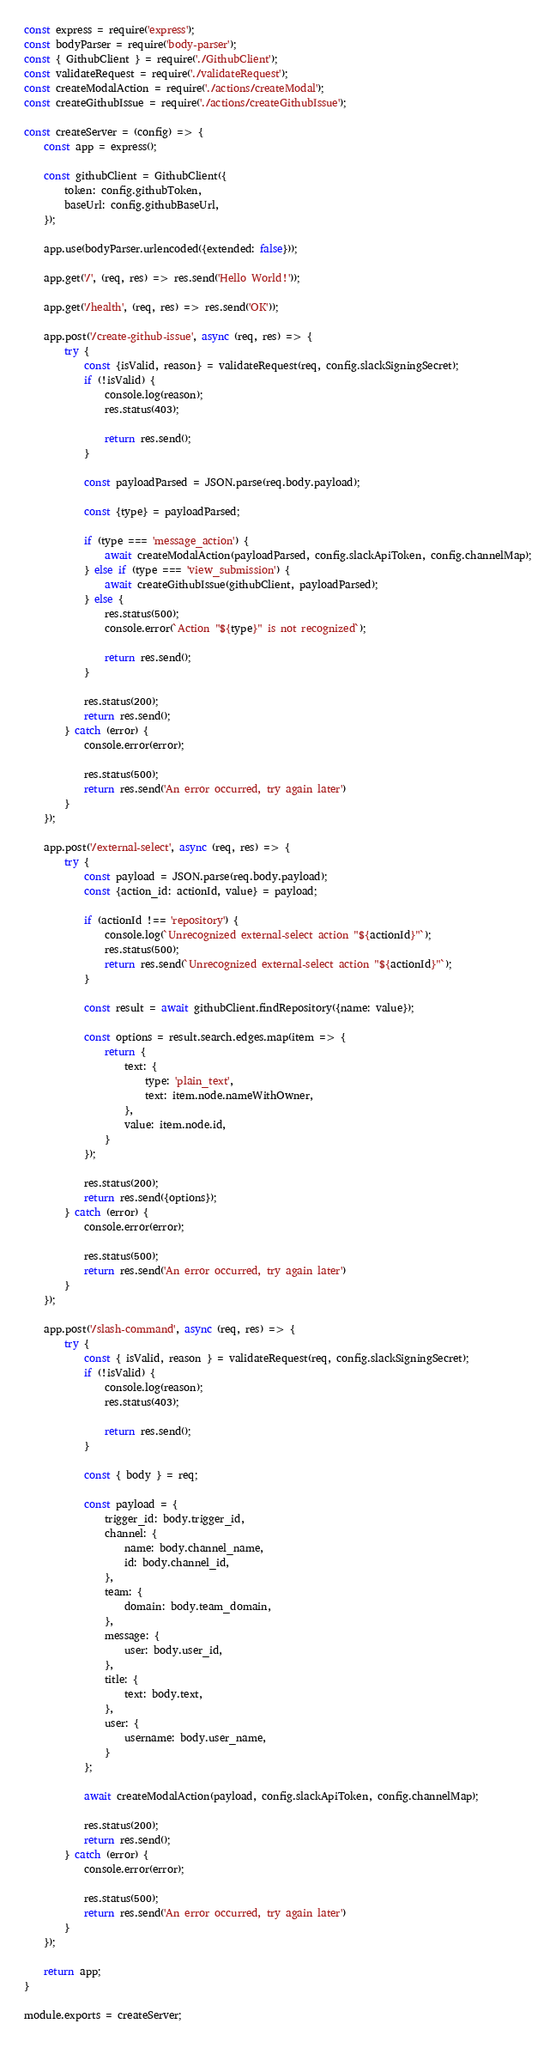<code> <loc_0><loc_0><loc_500><loc_500><_JavaScript_>const express = require('express');
const bodyParser = require('body-parser');
const { GithubClient } = require('./GithubClient');
const validateRequest = require('./validateRequest');
const createModalAction = require('./actions/createModal');
const createGithubIssue = require('./actions/createGithubIssue');

const createServer = (config) => {
    const app = express();

    const githubClient = GithubClient({
        token: config.githubToken,
        baseUrl: config.githubBaseUrl,
    });

    app.use(bodyParser.urlencoded({extended: false}));

    app.get('/', (req, res) => res.send('Hello World!'));

    app.get('/health', (req, res) => res.send('OK'));

    app.post('/create-github-issue', async (req, res) => {
        try {
            const {isValid, reason} = validateRequest(req, config.slackSigningSecret);
            if (!isValid) {
                console.log(reason);
                res.status(403);

                return res.send();
            }

            const payloadParsed = JSON.parse(req.body.payload);

            const {type} = payloadParsed;

            if (type === 'message_action') {
                await createModalAction(payloadParsed, config.slackApiToken, config.channelMap);
            } else if (type === 'view_submission') {
                await createGithubIssue(githubClient, payloadParsed);
            } else {
                res.status(500);
                console.error(`Action "${type}" is not recognized`);

                return res.send();
            }

            res.status(200);
            return res.send();
        } catch (error) {
            console.error(error);

            res.status(500);
            return res.send('An error occurred, try again later')
        }
    });

    app.post('/external-select', async (req, res) => {
        try {
            const payload = JSON.parse(req.body.payload);
            const {action_id: actionId, value} = payload;

            if (actionId !== 'repository') {
                console.log(`Unrecognized external-select action "${actionId}"`);
                res.status(500);
                return res.send(`Unrecognized external-select action "${actionId}"`);
            }

            const result = await githubClient.findRepository({name: value});

            const options = result.search.edges.map(item => {
                return {
                    text: {
                        type: 'plain_text',
                        text: item.node.nameWithOwner,
                    },
                    value: item.node.id,
                }
            });

            res.status(200);
            return res.send({options});
        } catch (error) {
            console.error(error);

            res.status(500);
            return res.send('An error occurred, try again later')
        }
    });

    app.post('/slash-command', async (req, res) => {
        try {
            const { isValid, reason } = validateRequest(req, config.slackSigningSecret);
            if (!isValid) {
                console.log(reason);
                res.status(403);

                return res.send();
            }

            const { body } = req;

            const payload = {
                trigger_id: body.trigger_id,
                channel: {
                    name: body.channel_name,
                    id: body.channel_id,
                },
                team: {
                    domain: body.team_domain,
                },
                message: {
                    user: body.user_id,
                },
                title: {
                    text: body.text,
                },
                user: {
                    username: body.user_name,
                }
            };

            await createModalAction(payload, config.slackApiToken, config.channelMap);

            res.status(200);
            return res.send();
        } catch (error) {
            console.error(error);

            res.status(500);
            return res.send('An error occurred, try again later')
        }
    });

    return app;
}

module.exports = createServer;
</code> 